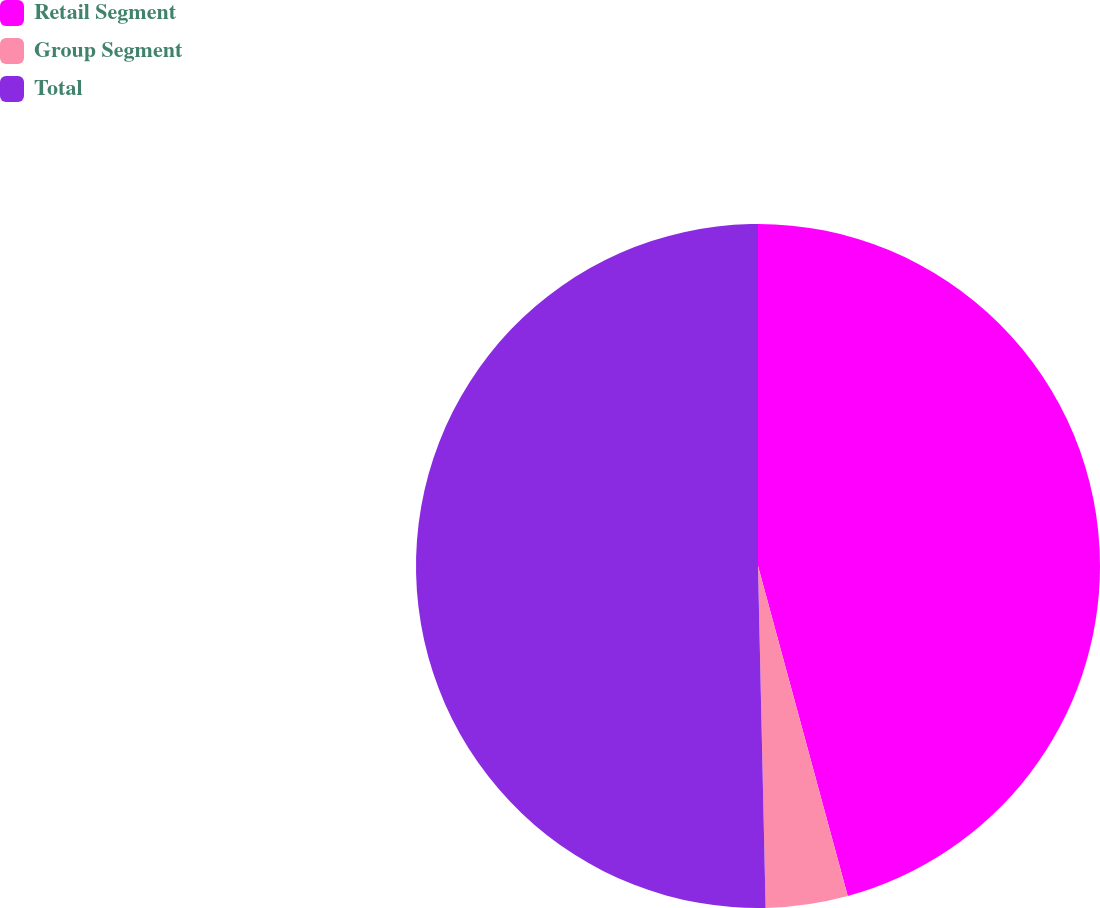Convert chart to OTSL. <chart><loc_0><loc_0><loc_500><loc_500><pie_chart><fcel>Retail Segment<fcel>Group Segment<fcel>Total<nl><fcel>45.77%<fcel>3.87%<fcel>50.35%<nl></chart> 